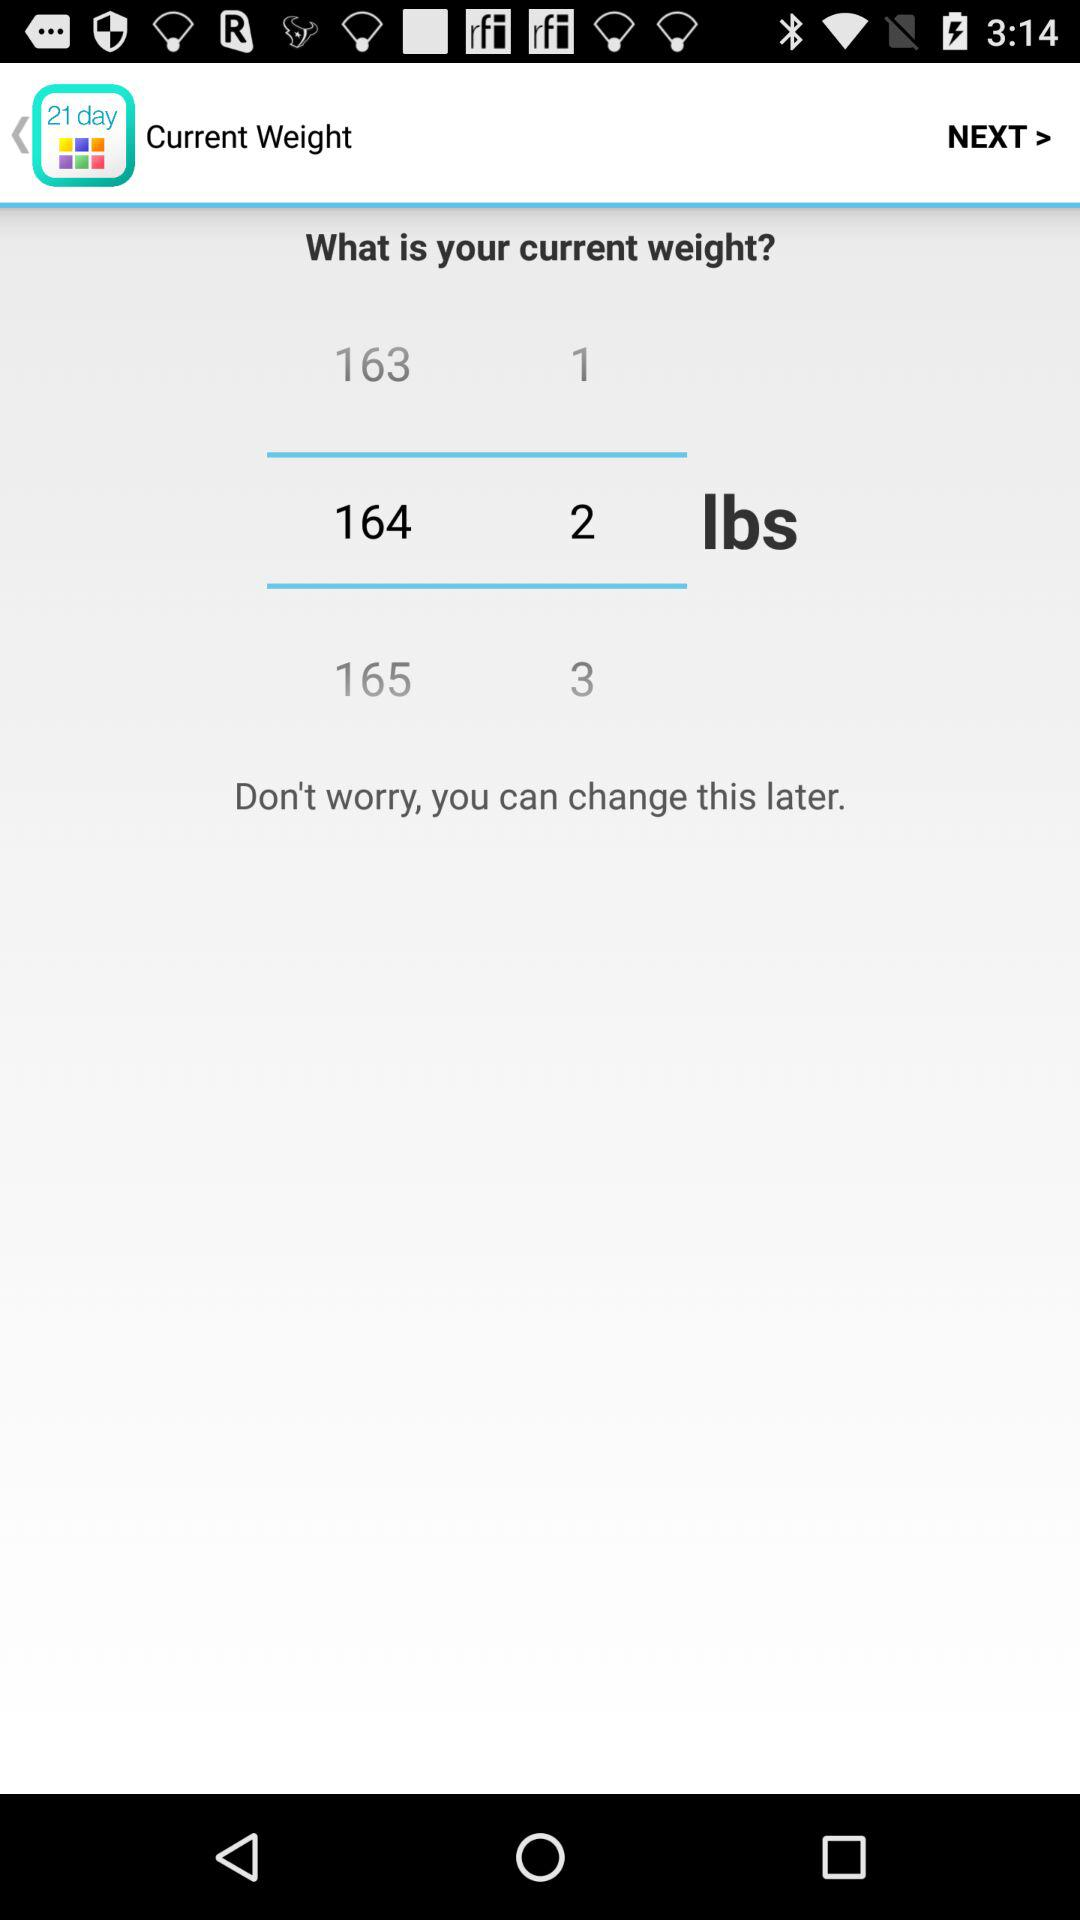What is the current weight? The current weight is 164.2 lbs. 